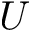<formula> <loc_0><loc_0><loc_500><loc_500>U</formula> 